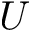<formula> <loc_0><loc_0><loc_500><loc_500>U</formula> 